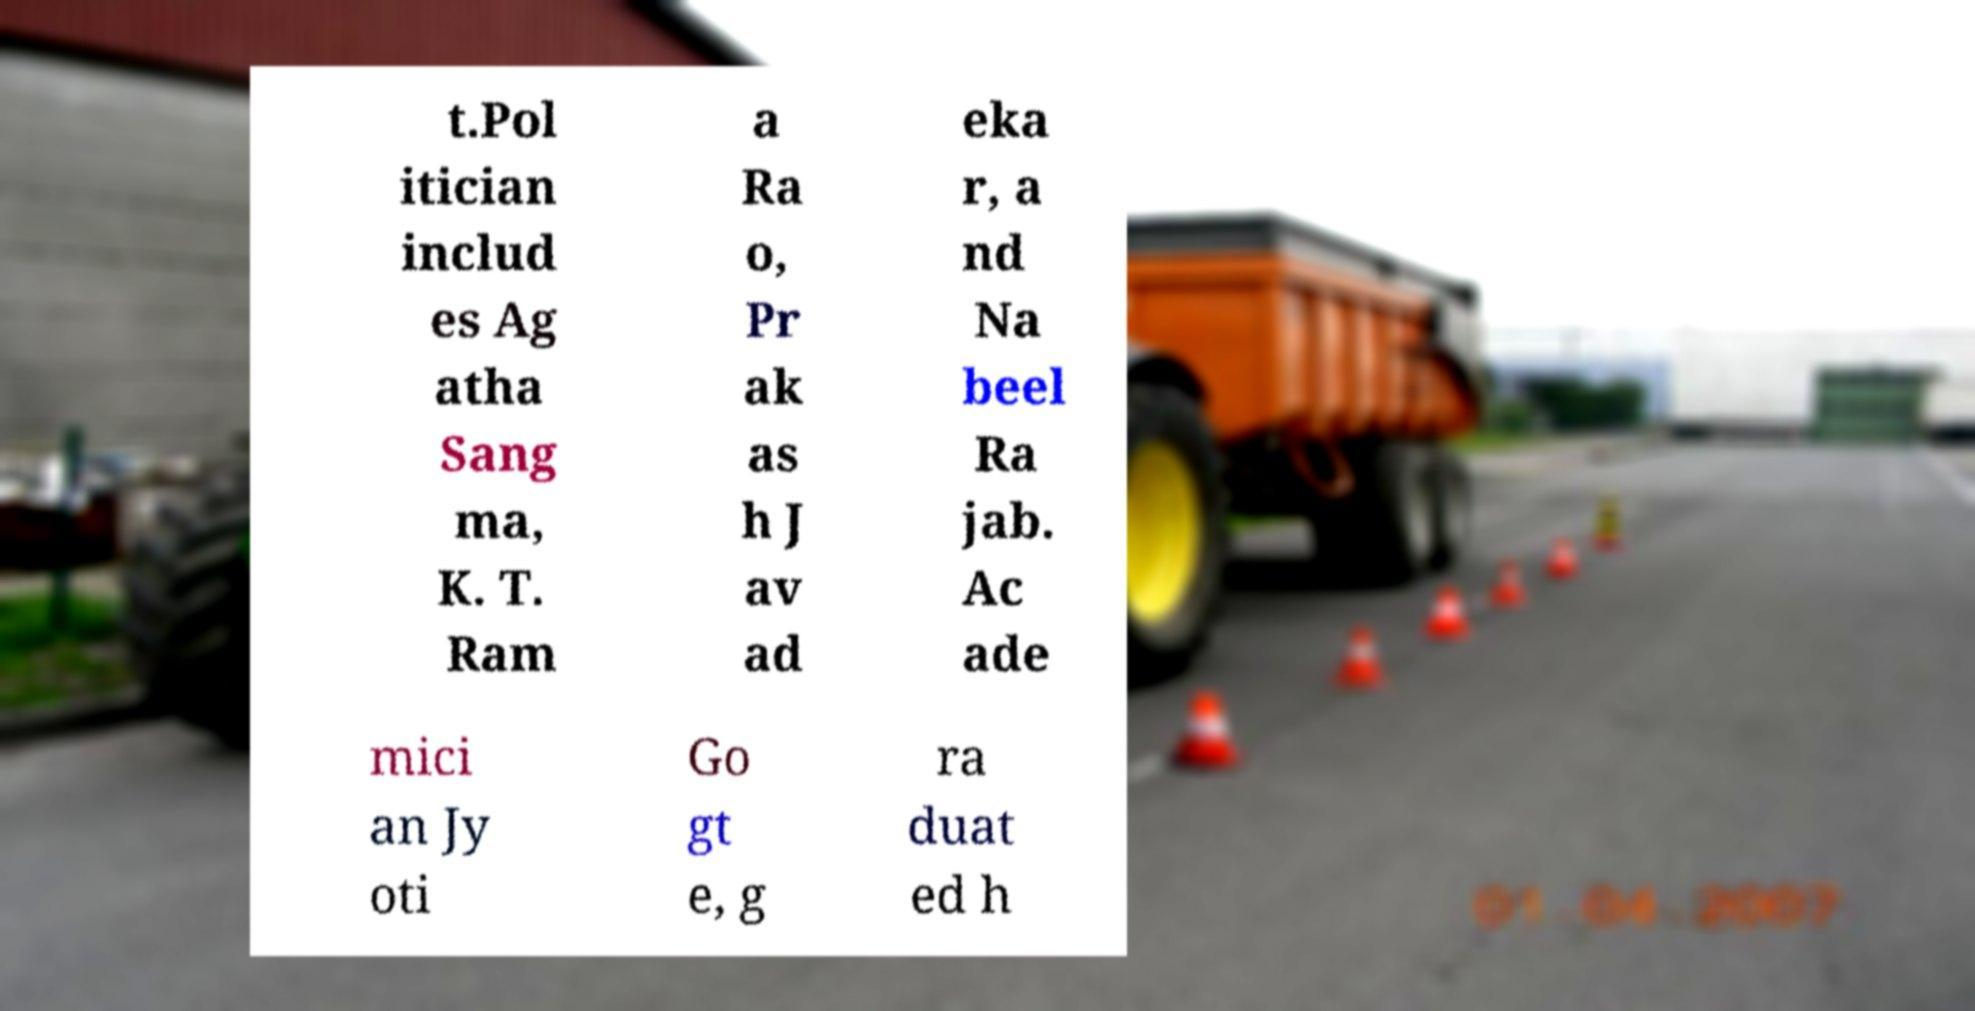Can you read and provide the text displayed in the image?This photo seems to have some interesting text. Can you extract and type it out for me? t.Pol itician includ es Ag atha Sang ma, K. T. Ram a Ra o, Pr ak as h J av ad eka r, a nd Na beel Ra jab. Ac ade mici an Jy oti Go gt e, g ra duat ed h 